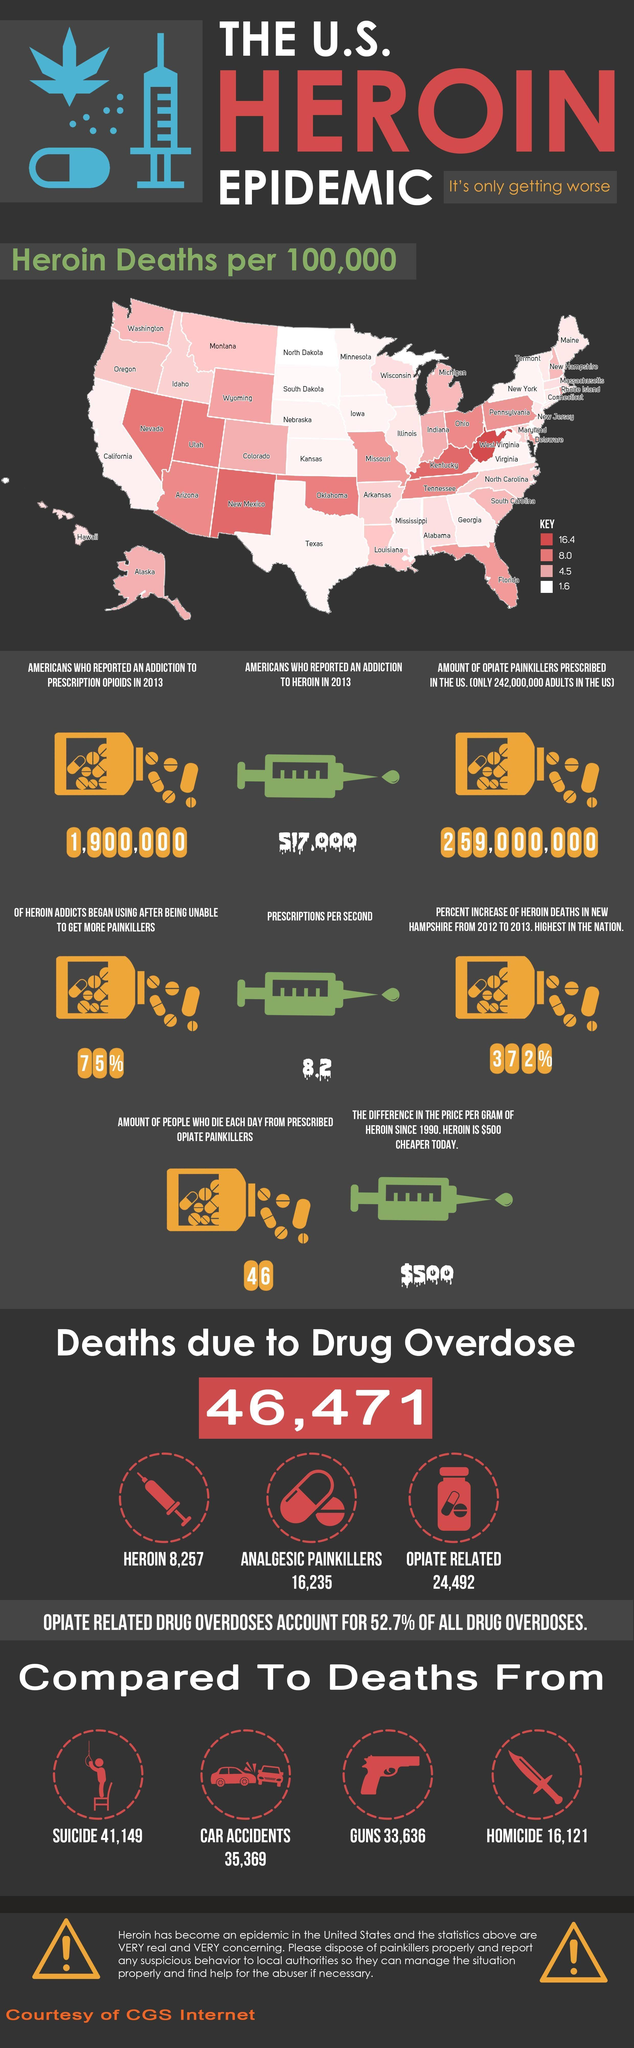What is the number of Americans who reported an addiction to heroin in 2013?
Answer the question with a short phrase. 517,000 What is the number of deaths per 100,000 in Colorado? 4.5 How many Americans reported an addiction to prescription opioids in 2013? 1,900,000 By what count is the number of deaths by suicide greater than that by heroin overdose? 32,892 What percent of dug overdose deaths are opiate related?(correct to two decimal places) 52.70 